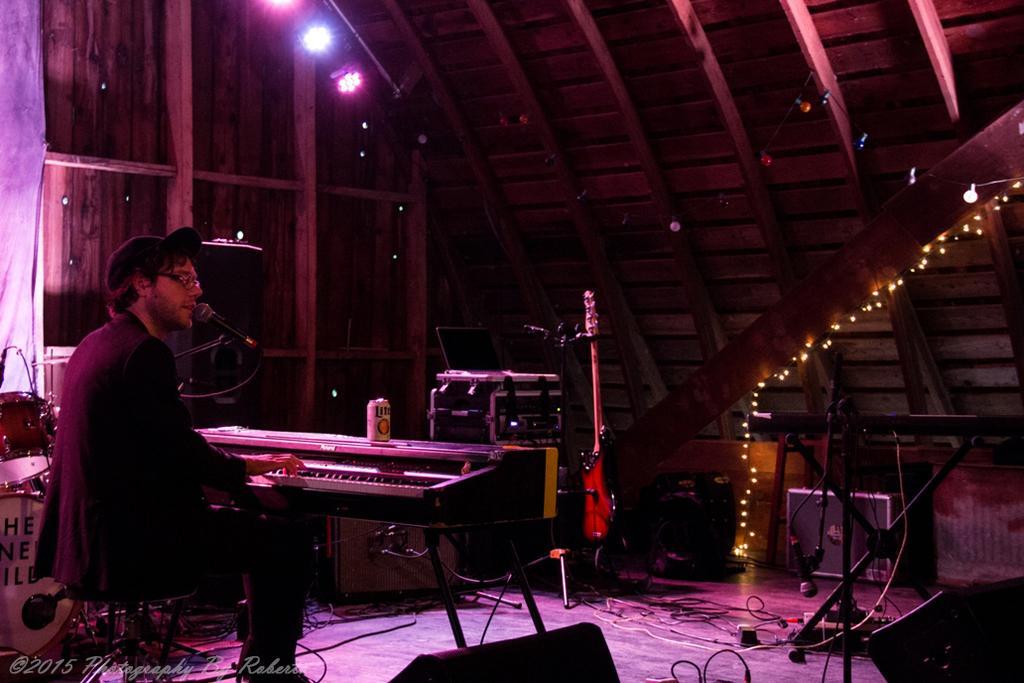Please provide a concise description of this image. This picture shows a man seated and playing piano and singing with the help of a microphone and we see few lights on the top 